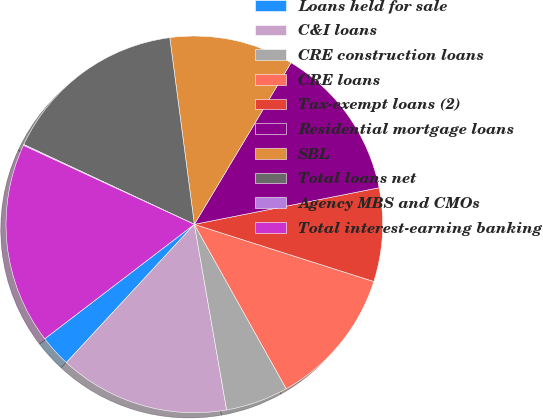Convert chart. <chart><loc_0><loc_0><loc_500><loc_500><pie_chart><fcel>Loans held for sale<fcel>C&I loans<fcel>CRE construction loans<fcel>CRE loans<fcel>Tax-exempt loans (2)<fcel>Residential mortgage loans<fcel>SBL<fcel>Total loans net<fcel>Agency MBS and CMOs<fcel>Total interest-earning banking<nl><fcel>2.72%<fcel>14.63%<fcel>5.37%<fcel>11.98%<fcel>8.02%<fcel>13.31%<fcel>10.66%<fcel>15.95%<fcel>0.08%<fcel>17.28%<nl></chart> 